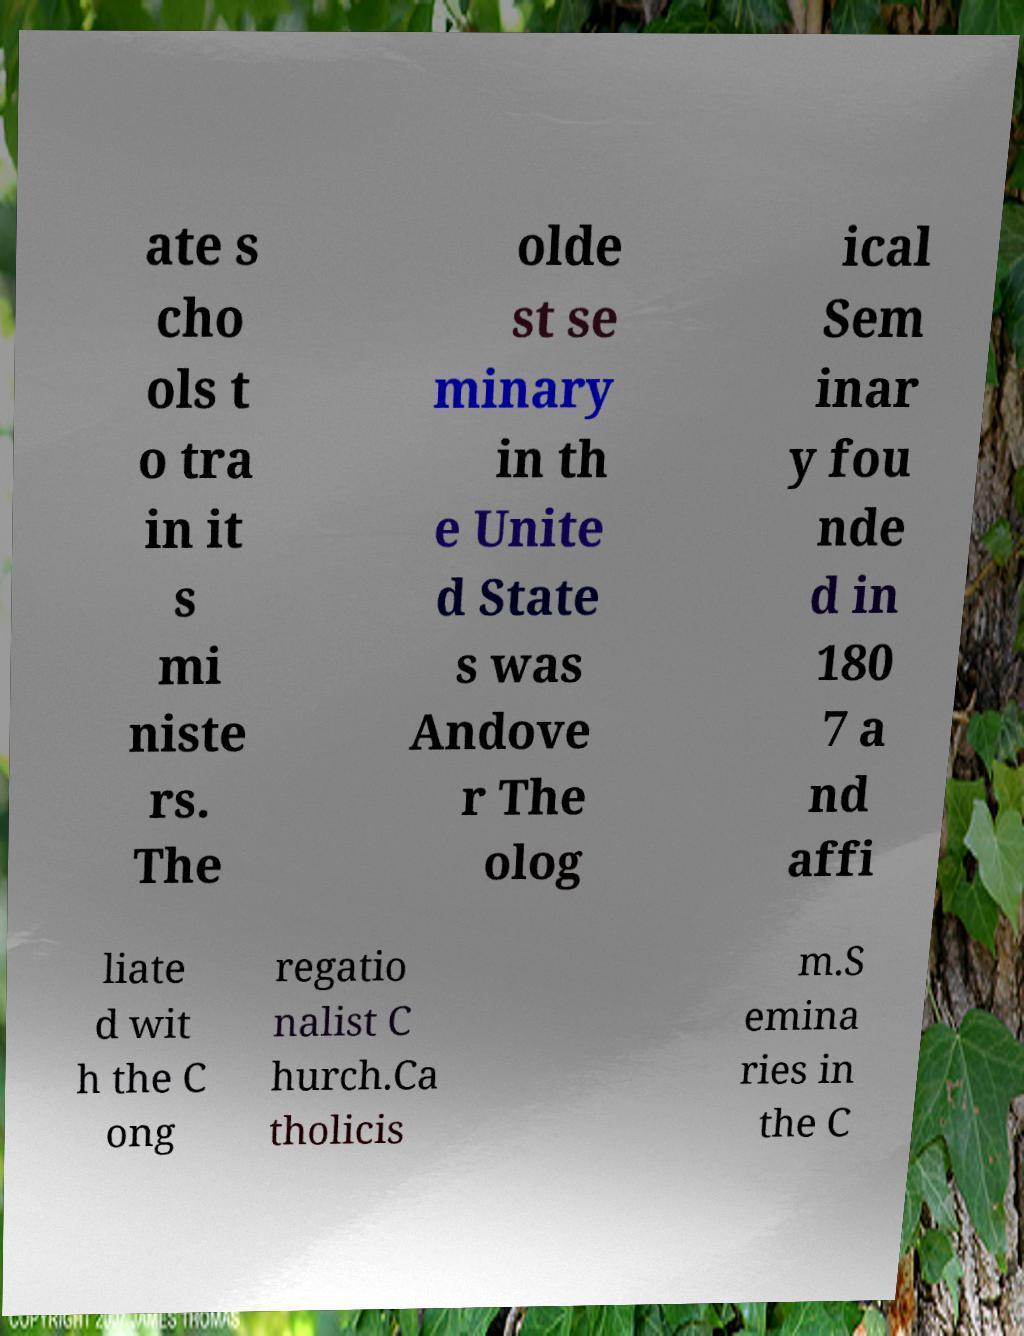Could you assist in decoding the text presented in this image and type it out clearly? ate s cho ols t o tra in it s mi niste rs. The olde st se minary in th e Unite d State s was Andove r The olog ical Sem inar y fou nde d in 180 7 a nd affi liate d wit h the C ong regatio nalist C hurch.Ca tholicis m.S emina ries in the C 